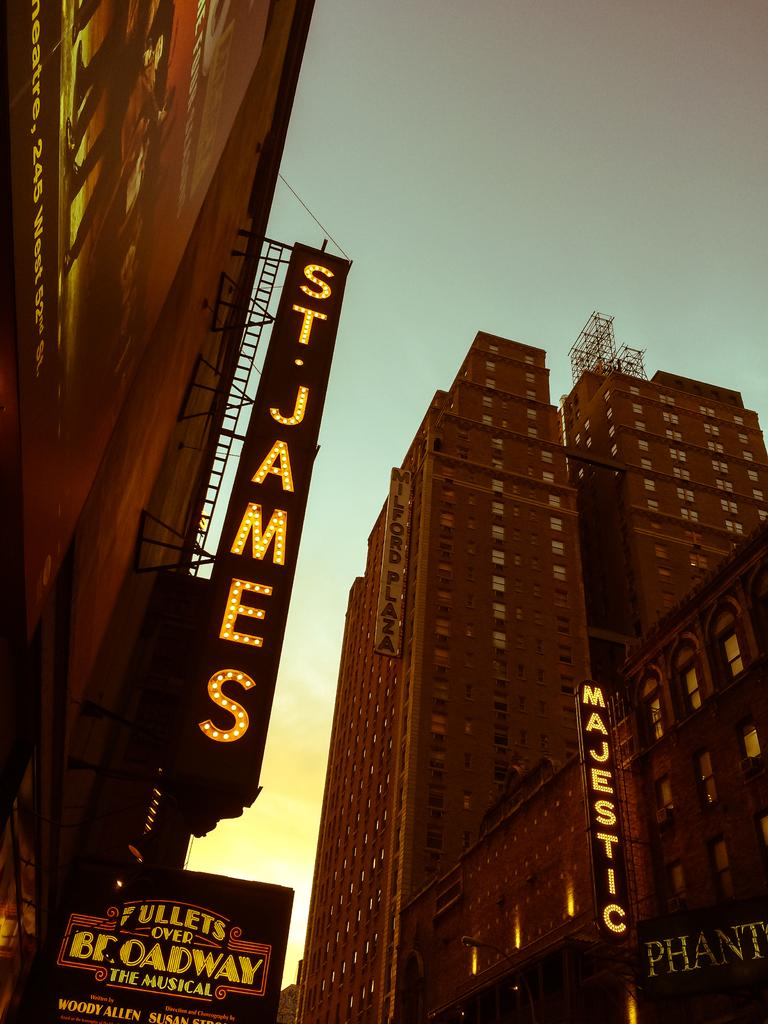What type of structures can be seen in the image? There are buildings in the image. What architectural feature is present in the image? There is a truss in the image. What type of decorations are visible in the image? There are banners in the image. What type of illumination is present in the image? There are lights in the image. What other objects can be seen in the image? There are other objects in the image. What can be seen in the background of the image? The sky is visible in the background of the image. Can you see any fairies flying around the buildings in the image? There are no fairies present in the image. What type of field can be seen in the image? There is no field present in the image. 